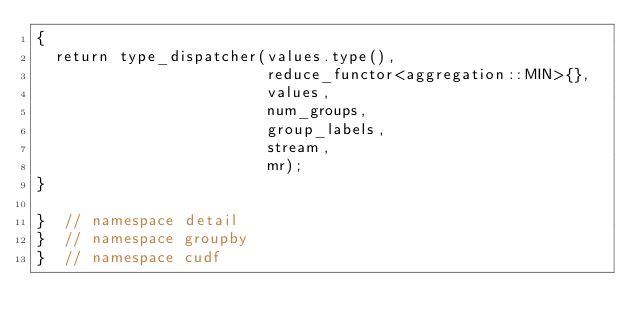Convert code to text. <code><loc_0><loc_0><loc_500><loc_500><_Cuda_>{
  return type_dispatcher(values.type(),
                         reduce_functor<aggregation::MIN>{},
                         values,
                         num_groups,
                         group_labels,
                         stream,
                         mr);
}

}  // namespace detail
}  // namespace groupby
}  // namespace cudf
</code> 